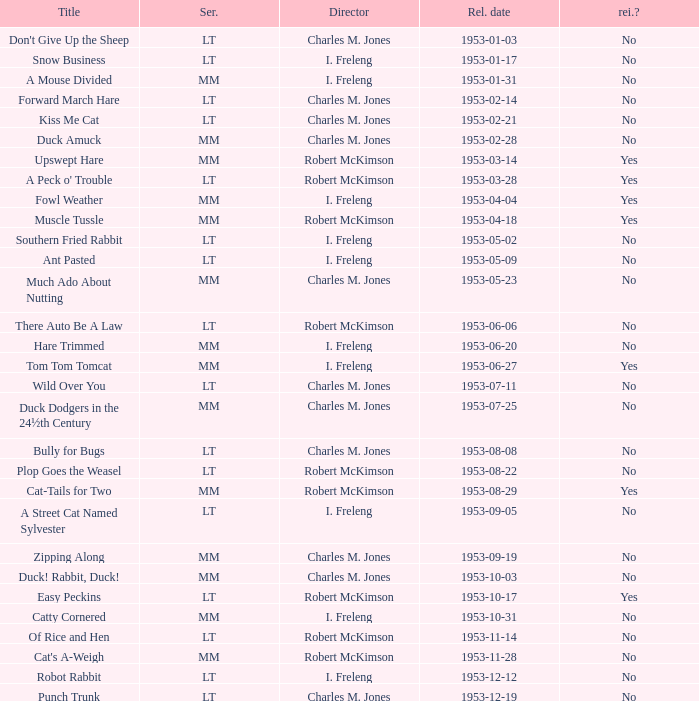Could you help me parse every detail presented in this table? {'header': ['Title', 'Ser.', 'Director', 'Rel. date', 'rei.?'], 'rows': [["Don't Give Up the Sheep", 'LT', 'Charles M. Jones', '1953-01-03', 'No'], ['Snow Business', 'LT', 'I. Freleng', '1953-01-17', 'No'], ['A Mouse Divided', 'MM', 'I. Freleng', '1953-01-31', 'No'], ['Forward March Hare', 'LT', 'Charles M. Jones', '1953-02-14', 'No'], ['Kiss Me Cat', 'LT', 'Charles M. Jones', '1953-02-21', 'No'], ['Duck Amuck', 'MM', 'Charles M. Jones', '1953-02-28', 'No'], ['Upswept Hare', 'MM', 'Robert McKimson', '1953-03-14', 'Yes'], ["A Peck o' Trouble", 'LT', 'Robert McKimson', '1953-03-28', 'Yes'], ['Fowl Weather', 'MM', 'I. Freleng', '1953-04-04', 'Yes'], ['Muscle Tussle', 'MM', 'Robert McKimson', '1953-04-18', 'Yes'], ['Southern Fried Rabbit', 'LT', 'I. Freleng', '1953-05-02', 'No'], ['Ant Pasted', 'LT', 'I. Freleng', '1953-05-09', 'No'], ['Much Ado About Nutting', 'MM', 'Charles M. Jones', '1953-05-23', 'No'], ['There Auto Be A Law', 'LT', 'Robert McKimson', '1953-06-06', 'No'], ['Hare Trimmed', 'MM', 'I. Freleng', '1953-06-20', 'No'], ['Tom Tom Tomcat', 'MM', 'I. Freleng', '1953-06-27', 'Yes'], ['Wild Over You', 'LT', 'Charles M. Jones', '1953-07-11', 'No'], ['Duck Dodgers in the 24½th Century', 'MM', 'Charles M. Jones', '1953-07-25', 'No'], ['Bully for Bugs', 'LT', 'Charles M. Jones', '1953-08-08', 'No'], ['Plop Goes the Weasel', 'LT', 'Robert McKimson', '1953-08-22', 'No'], ['Cat-Tails for Two', 'MM', 'Robert McKimson', '1953-08-29', 'Yes'], ['A Street Cat Named Sylvester', 'LT', 'I. Freleng', '1953-09-05', 'No'], ['Zipping Along', 'MM', 'Charles M. Jones', '1953-09-19', 'No'], ['Duck! Rabbit, Duck!', 'MM', 'Charles M. Jones', '1953-10-03', 'No'], ['Easy Peckins', 'LT', 'Robert McKimson', '1953-10-17', 'Yes'], ['Catty Cornered', 'MM', 'I. Freleng', '1953-10-31', 'No'], ['Of Rice and Hen', 'LT', 'Robert McKimson', '1953-11-14', 'No'], ["Cat's A-Weigh", 'MM', 'Robert McKimson', '1953-11-28', 'No'], ['Robot Rabbit', 'LT', 'I. Freleng', '1953-12-12', 'No'], ['Punch Trunk', 'LT', 'Charles M. Jones', '1953-12-19', 'No']]} Was there a reissue of the film released on 1953-10-03? No. 